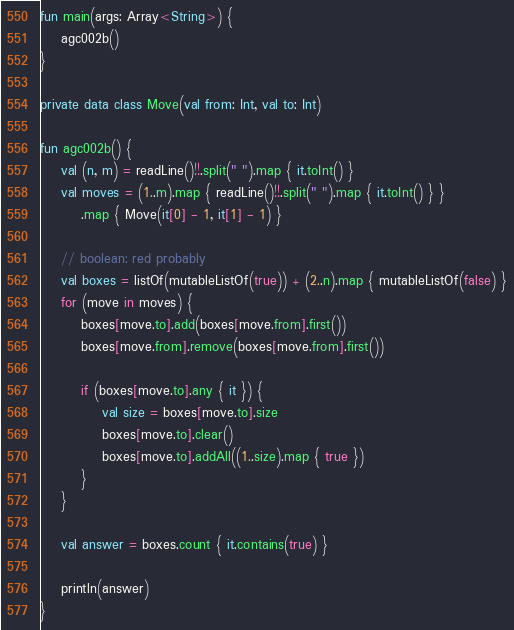<code> <loc_0><loc_0><loc_500><loc_500><_Kotlin_>fun main(args: Array<String>) {
    agc002b()
}

private data class Move(val from: Int, val to: Int)

fun agc002b() {
    val (n, m) = readLine()!!.split(" ").map { it.toInt() }
    val moves = (1..m).map { readLine()!!.split(" ").map { it.toInt() } }
        .map { Move(it[0] - 1, it[1] - 1) }

    // boolean: red probably
    val boxes = listOf(mutableListOf(true)) + (2..n).map { mutableListOf(false) }
    for (move in moves) {
        boxes[move.to].add(boxes[move.from].first())
        boxes[move.from].remove(boxes[move.from].first())

        if (boxes[move.to].any { it }) {
            val size = boxes[move.to].size
            boxes[move.to].clear()
            boxes[move.to].addAll((1..size).map { true })
        }
    }

    val answer = boxes.count { it.contains(true) }

    println(answer)
}
</code> 